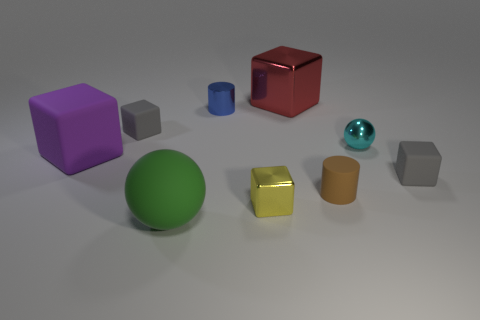Is there a pattern or theme to the arrangement of the objects in the image? The image shows a random assortment of objects with different shapes and colors, placed with spacing between them. There doesn't seem to be a specific pattern or theme to their arrangement, but rather it showcases a variety of geometric shapes and a spectrum of colors. 